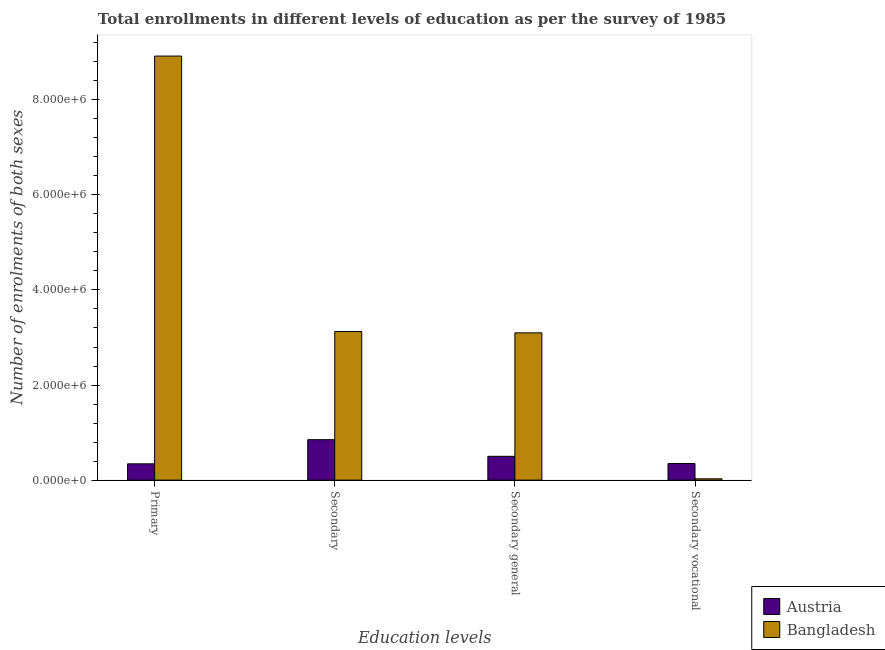How many groups of bars are there?
Your answer should be very brief. 4. Are the number of bars per tick equal to the number of legend labels?
Your answer should be compact. Yes. Are the number of bars on each tick of the X-axis equal?
Keep it short and to the point. Yes. How many bars are there on the 3rd tick from the left?
Your answer should be very brief. 2. What is the label of the 3rd group of bars from the left?
Keep it short and to the point. Secondary general. What is the number of enrolments in secondary education in Bangladesh?
Provide a short and direct response. 3.13e+06. Across all countries, what is the maximum number of enrolments in secondary vocational education?
Your answer should be very brief. 3.50e+05. Across all countries, what is the minimum number of enrolments in secondary general education?
Offer a terse response. 5.01e+05. What is the total number of enrolments in secondary vocational education in the graph?
Ensure brevity in your answer.  3.77e+05. What is the difference between the number of enrolments in secondary education in Austria and that in Bangladesh?
Give a very brief answer. -2.27e+06. What is the difference between the number of enrolments in secondary vocational education in Bangladesh and the number of enrolments in secondary education in Austria?
Your answer should be compact. -8.23e+05. What is the average number of enrolments in primary education per country?
Your answer should be compact. 4.63e+06. What is the difference between the number of enrolments in secondary education and number of enrolments in secondary vocational education in Bangladesh?
Offer a terse response. 3.10e+06. What is the ratio of the number of enrolments in primary education in Austria to that in Bangladesh?
Provide a succinct answer. 0.04. Is the number of enrolments in secondary vocational education in Austria less than that in Bangladesh?
Ensure brevity in your answer.  No. Is the difference between the number of enrolments in secondary general education in Bangladesh and Austria greater than the difference between the number of enrolments in secondary vocational education in Bangladesh and Austria?
Offer a very short reply. Yes. What is the difference between the highest and the second highest number of enrolments in secondary vocational education?
Your response must be concise. 3.23e+05. What is the difference between the highest and the lowest number of enrolments in secondary vocational education?
Provide a succinct answer. 3.23e+05. What does the 1st bar from the left in Secondary represents?
Make the answer very short. Austria. Is it the case that in every country, the sum of the number of enrolments in primary education and number of enrolments in secondary education is greater than the number of enrolments in secondary general education?
Provide a succinct answer. Yes. Are all the bars in the graph horizontal?
Keep it short and to the point. No. How many countries are there in the graph?
Your answer should be compact. 2. Are the values on the major ticks of Y-axis written in scientific E-notation?
Keep it short and to the point. Yes. Does the graph contain any zero values?
Offer a very short reply. No. Does the graph contain grids?
Offer a very short reply. No. Where does the legend appear in the graph?
Provide a succinct answer. Bottom right. How are the legend labels stacked?
Your response must be concise. Vertical. What is the title of the graph?
Keep it short and to the point. Total enrollments in different levels of education as per the survey of 1985. What is the label or title of the X-axis?
Ensure brevity in your answer.  Education levels. What is the label or title of the Y-axis?
Provide a short and direct response. Number of enrolments of both sexes. What is the Number of enrolments of both sexes of Austria in Primary?
Provide a short and direct response. 3.43e+05. What is the Number of enrolments of both sexes in Bangladesh in Primary?
Your answer should be very brief. 8.92e+06. What is the Number of enrolments of both sexes of Austria in Secondary?
Your answer should be compact. 8.51e+05. What is the Number of enrolments of both sexes of Bangladesh in Secondary?
Your answer should be very brief. 3.13e+06. What is the Number of enrolments of both sexes in Austria in Secondary general?
Keep it short and to the point. 5.01e+05. What is the Number of enrolments of both sexes of Bangladesh in Secondary general?
Offer a very short reply. 3.10e+06. What is the Number of enrolments of both sexes of Austria in Secondary vocational?
Give a very brief answer. 3.50e+05. What is the Number of enrolments of both sexes in Bangladesh in Secondary vocational?
Provide a short and direct response. 2.73e+04. Across all Education levels, what is the maximum Number of enrolments of both sexes of Austria?
Keep it short and to the point. 8.51e+05. Across all Education levels, what is the maximum Number of enrolments of both sexes of Bangladesh?
Offer a terse response. 8.92e+06. Across all Education levels, what is the minimum Number of enrolments of both sexes in Austria?
Make the answer very short. 3.43e+05. Across all Education levels, what is the minimum Number of enrolments of both sexes of Bangladesh?
Offer a terse response. 2.73e+04. What is the total Number of enrolments of both sexes in Austria in the graph?
Your answer should be compact. 2.04e+06. What is the total Number of enrolments of both sexes of Bangladesh in the graph?
Offer a terse response. 1.52e+07. What is the difference between the Number of enrolments of both sexes in Austria in Primary and that in Secondary?
Your answer should be compact. -5.08e+05. What is the difference between the Number of enrolments of both sexes of Bangladesh in Primary and that in Secondary?
Keep it short and to the point. 5.80e+06. What is the difference between the Number of enrolments of both sexes in Austria in Primary and that in Secondary general?
Your response must be concise. -1.58e+05. What is the difference between the Number of enrolments of both sexes of Bangladesh in Primary and that in Secondary general?
Provide a succinct answer. 5.82e+06. What is the difference between the Number of enrolments of both sexes of Austria in Primary and that in Secondary vocational?
Your answer should be very brief. -7172. What is the difference between the Number of enrolments of both sexes of Bangladesh in Primary and that in Secondary vocational?
Offer a terse response. 8.89e+06. What is the difference between the Number of enrolments of both sexes in Austria in Secondary and that in Secondary general?
Your answer should be very brief. 3.50e+05. What is the difference between the Number of enrolments of both sexes in Bangladesh in Secondary and that in Secondary general?
Ensure brevity in your answer.  2.73e+04. What is the difference between the Number of enrolments of both sexes in Austria in Secondary and that in Secondary vocational?
Your answer should be compact. 5.01e+05. What is the difference between the Number of enrolments of both sexes in Bangladesh in Secondary and that in Secondary vocational?
Your answer should be compact. 3.10e+06. What is the difference between the Number of enrolments of both sexes in Austria in Secondary general and that in Secondary vocational?
Your answer should be compact. 1.51e+05. What is the difference between the Number of enrolments of both sexes of Bangladesh in Secondary general and that in Secondary vocational?
Make the answer very short. 3.07e+06. What is the difference between the Number of enrolments of both sexes of Austria in Primary and the Number of enrolments of both sexes of Bangladesh in Secondary?
Ensure brevity in your answer.  -2.78e+06. What is the difference between the Number of enrolments of both sexes in Austria in Primary and the Number of enrolments of both sexes in Bangladesh in Secondary general?
Your answer should be compact. -2.76e+06. What is the difference between the Number of enrolments of both sexes in Austria in Primary and the Number of enrolments of both sexes in Bangladesh in Secondary vocational?
Ensure brevity in your answer.  3.15e+05. What is the difference between the Number of enrolments of both sexes of Austria in Secondary and the Number of enrolments of both sexes of Bangladesh in Secondary general?
Offer a terse response. -2.25e+06. What is the difference between the Number of enrolments of both sexes of Austria in Secondary and the Number of enrolments of both sexes of Bangladesh in Secondary vocational?
Offer a terse response. 8.23e+05. What is the difference between the Number of enrolments of both sexes of Austria in Secondary general and the Number of enrolments of both sexes of Bangladesh in Secondary vocational?
Offer a terse response. 4.73e+05. What is the average Number of enrolments of both sexes of Austria per Education levels?
Keep it short and to the point. 5.11e+05. What is the average Number of enrolments of both sexes in Bangladesh per Education levels?
Keep it short and to the point. 3.79e+06. What is the difference between the Number of enrolments of both sexes of Austria and Number of enrolments of both sexes of Bangladesh in Primary?
Offer a terse response. -8.58e+06. What is the difference between the Number of enrolments of both sexes of Austria and Number of enrolments of both sexes of Bangladesh in Secondary?
Give a very brief answer. -2.27e+06. What is the difference between the Number of enrolments of both sexes in Austria and Number of enrolments of both sexes in Bangladesh in Secondary general?
Give a very brief answer. -2.60e+06. What is the difference between the Number of enrolments of both sexes in Austria and Number of enrolments of both sexes in Bangladesh in Secondary vocational?
Provide a short and direct response. 3.23e+05. What is the ratio of the Number of enrolments of both sexes in Austria in Primary to that in Secondary?
Your answer should be compact. 0.4. What is the ratio of the Number of enrolments of both sexes of Bangladesh in Primary to that in Secondary?
Keep it short and to the point. 2.85. What is the ratio of the Number of enrolments of both sexes of Austria in Primary to that in Secondary general?
Make the answer very short. 0.68. What is the ratio of the Number of enrolments of both sexes in Bangladesh in Primary to that in Secondary general?
Ensure brevity in your answer.  2.88. What is the ratio of the Number of enrolments of both sexes of Austria in Primary to that in Secondary vocational?
Make the answer very short. 0.98. What is the ratio of the Number of enrolments of both sexes of Bangladesh in Primary to that in Secondary vocational?
Give a very brief answer. 326.18. What is the ratio of the Number of enrolments of both sexes in Austria in Secondary to that in Secondary general?
Your answer should be very brief. 1.7. What is the ratio of the Number of enrolments of both sexes of Bangladesh in Secondary to that in Secondary general?
Your answer should be compact. 1.01. What is the ratio of the Number of enrolments of both sexes in Austria in Secondary to that in Secondary vocational?
Offer a very short reply. 2.43. What is the ratio of the Number of enrolments of both sexes of Bangladesh in Secondary to that in Secondary vocational?
Make the answer very short. 114.28. What is the ratio of the Number of enrolments of both sexes in Austria in Secondary general to that in Secondary vocational?
Ensure brevity in your answer.  1.43. What is the ratio of the Number of enrolments of both sexes in Bangladesh in Secondary general to that in Secondary vocational?
Offer a terse response. 113.28. What is the difference between the highest and the second highest Number of enrolments of both sexes in Austria?
Ensure brevity in your answer.  3.50e+05. What is the difference between the highest and the second highest Number of enrolments of both sexes in Bangladesh?
Make the answer very short. 5.80e+06. What is the difference between the highest and the lowest Number of enrolments of both sexes of Austria?
Ensure brevity in your answer.  5.08e+05. What is the difference between the highest and the lowest Number of enrolments of both sexes in Bangladesh?
Give a very brief answer. 8.89e+06. 